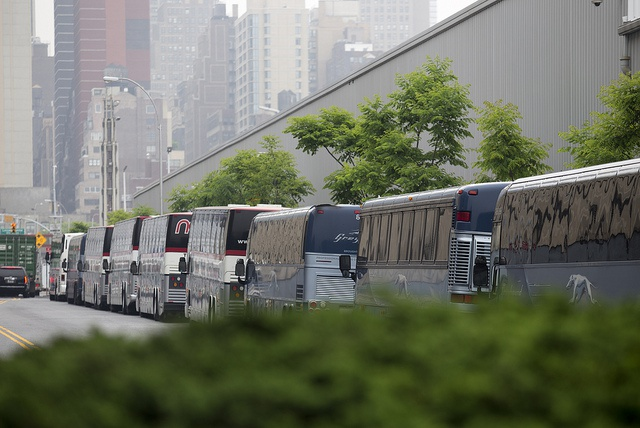Describe the objects in this image and their specific colors. I can see bus in darkgray, gray, black, darkgreen, and lightgray tones, bus in darkgray, gray, and black tones, bus in darkgray, gray, and black tones, bus in darkgray, gray, black, and lightgray tones, and bus in darkgray, black, gray, and lightgray tones in this image. 